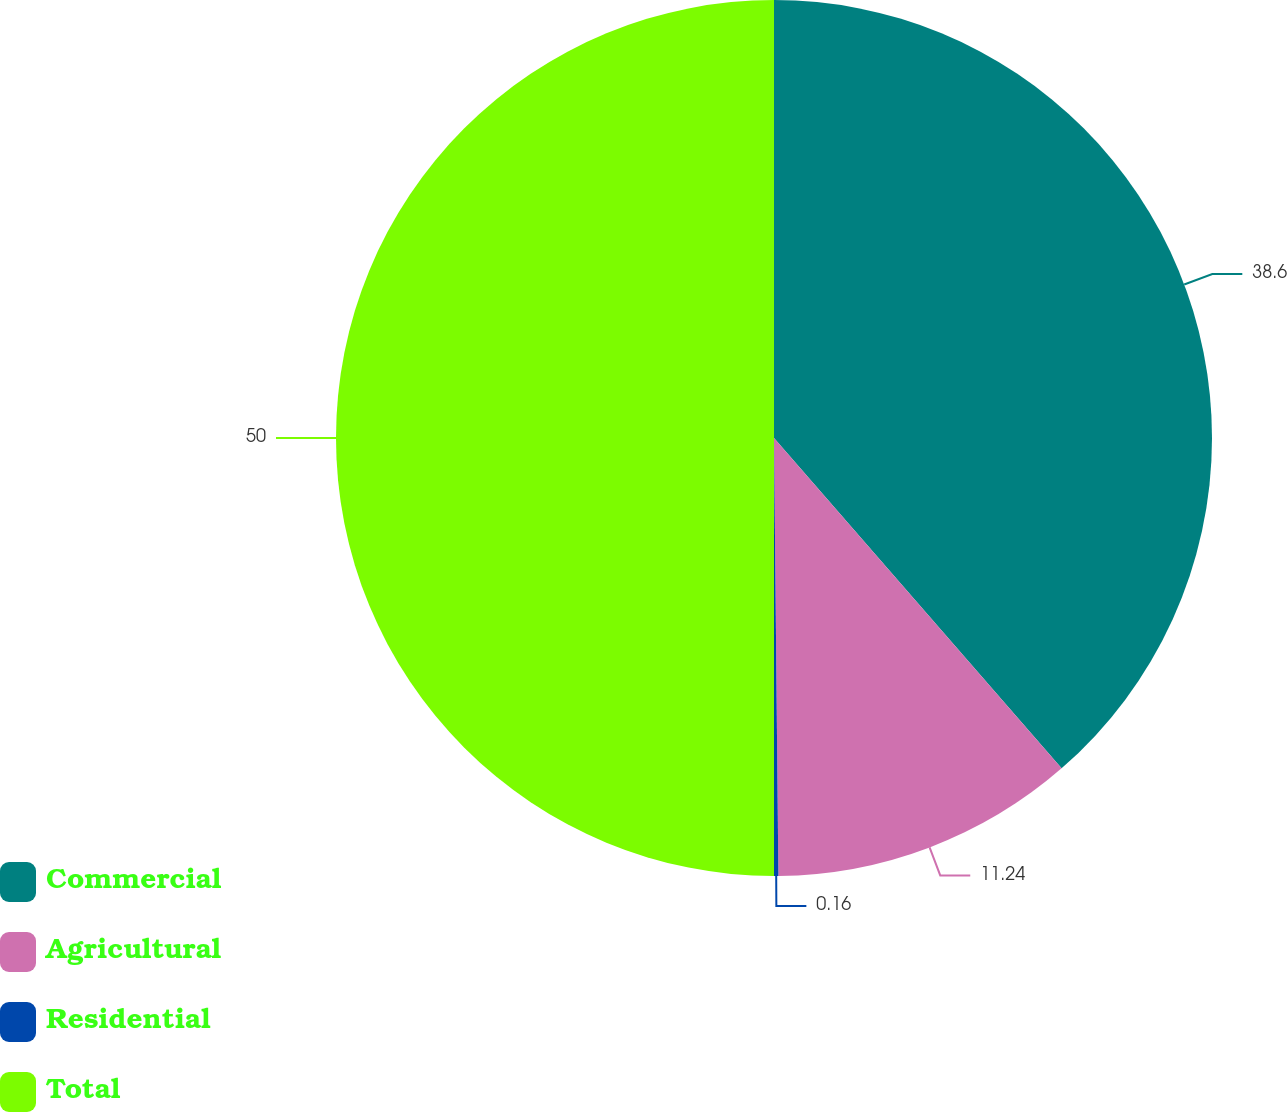Convert chart. <chart><loc_0><loc_0><loc_500><loc_500><pie_chart><fcel>Commercial<fcel>Agricultural<fcel>Residential<fcel>Total<nl><fcel>38.6%<fcel>11.24%<fcel>0.16%<fcel>50.0%<nl></chart> 